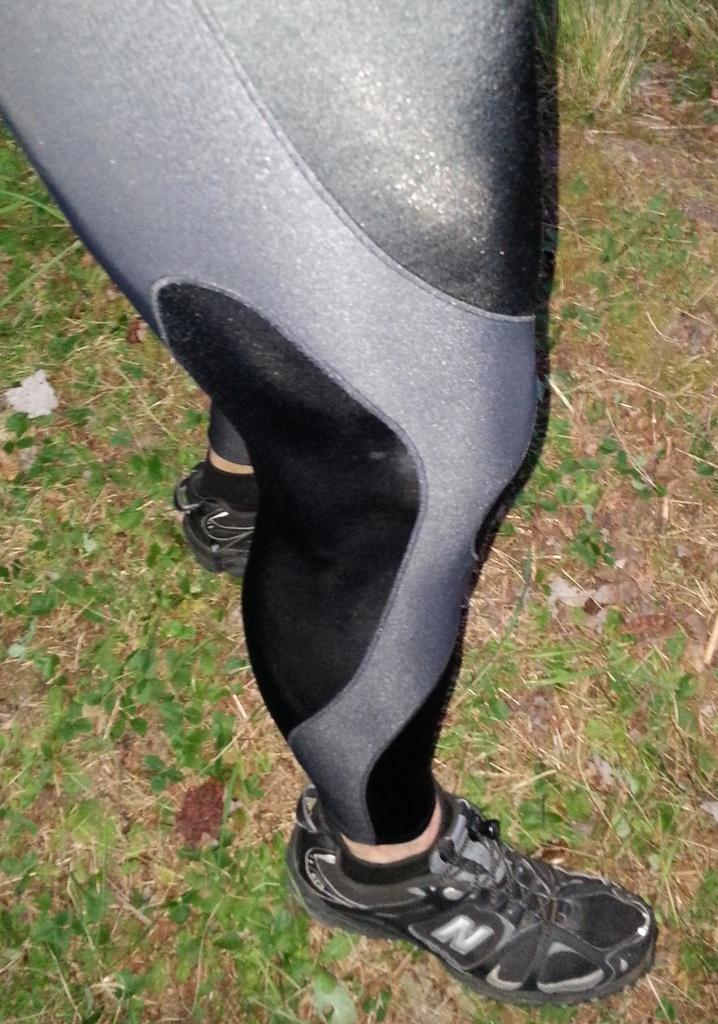How would you summarize this image in a sentence or two? In this image we can see a man is standing on the grassy land. He is wearing black color shoes and black-grey color dress. 